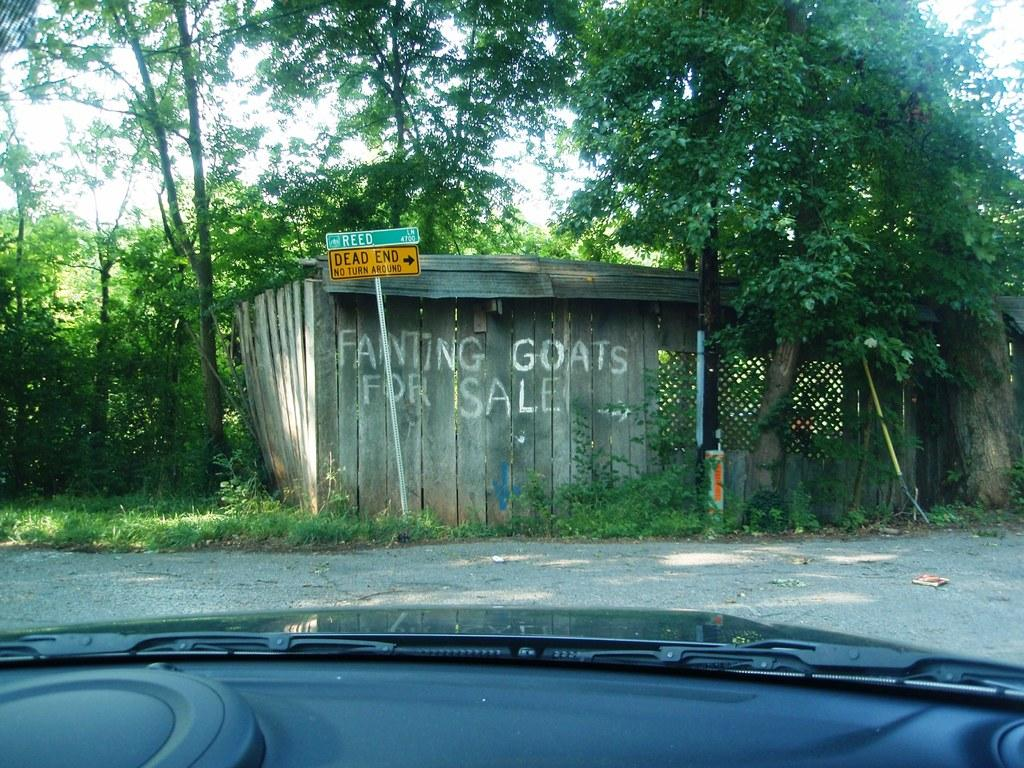What object is depicted as being inside the vehicle in the image? There is a glass of a vehicle in the image. What structure can be seen outside the vehicle in the image? There is a shed visible outside the vehicle in the image. What type of vegetation is present in the image? There are green color trees in the image. Can you tell me how many umbrellas are hanging from the trees in the image? There are no umbrellas hanging from the trees in the image; only green color trees are present. What type of bell can be heard ringing in the image? There is no bell present in the image, and therefore no such sound can be heard. 